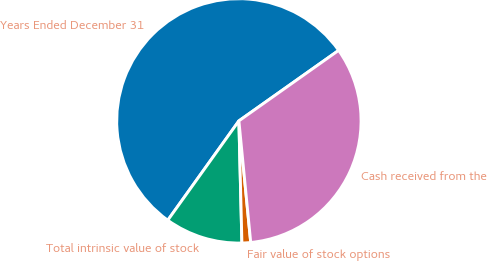<chart> <loc_0><loc_0><loc_500><loc_500><pie_chart><fcel>Years Ended December 31<fcel>Total intrinsic value of stock<fcel>Fair value of stock options<fcel>Cash received from the<nl><fcel>55.32%<fcel>10.28%<fcel>1.15%<fcel>33.25%<nl></chart> 